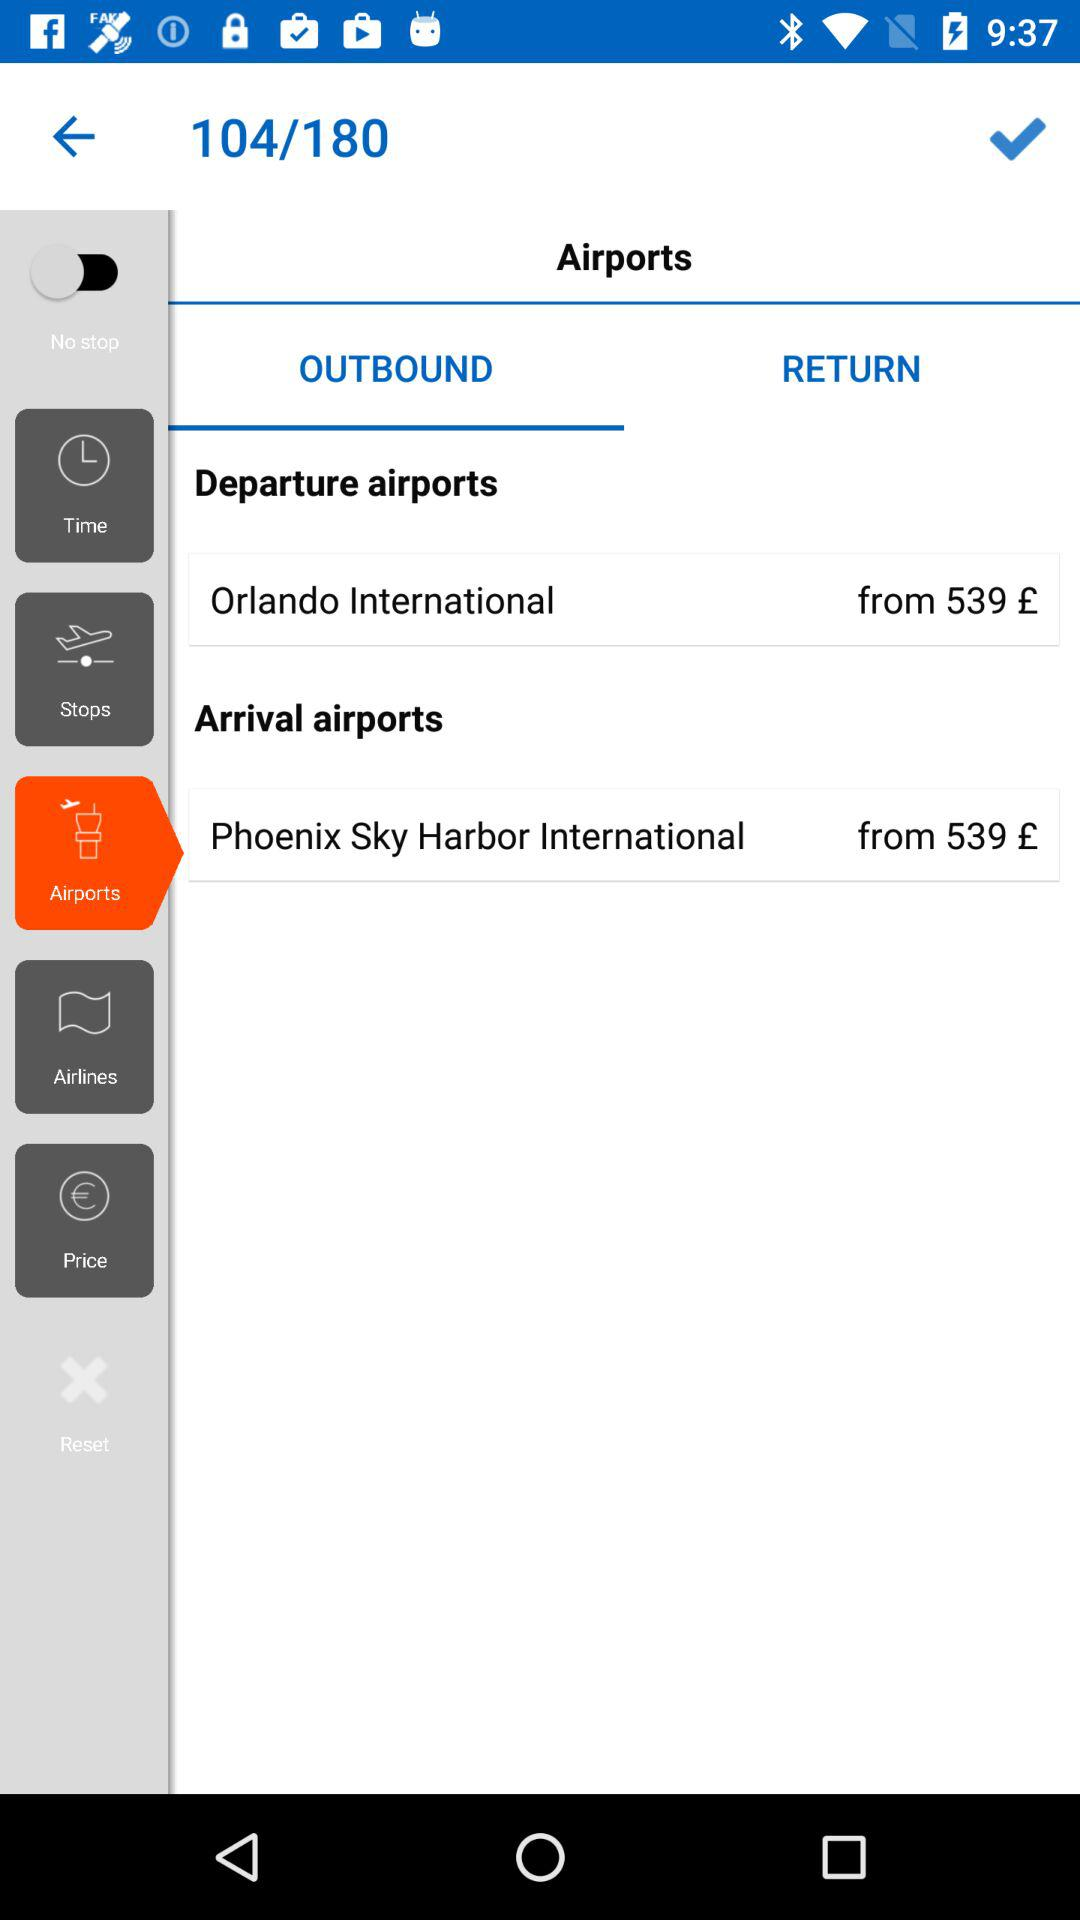What is the name of the departure airport? The name of the departure airport is "Orlando International". 